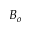Convert formula to latex. <formula><loc_0><loc_0><loc_500><loc_500>B _ { o }</formula> 